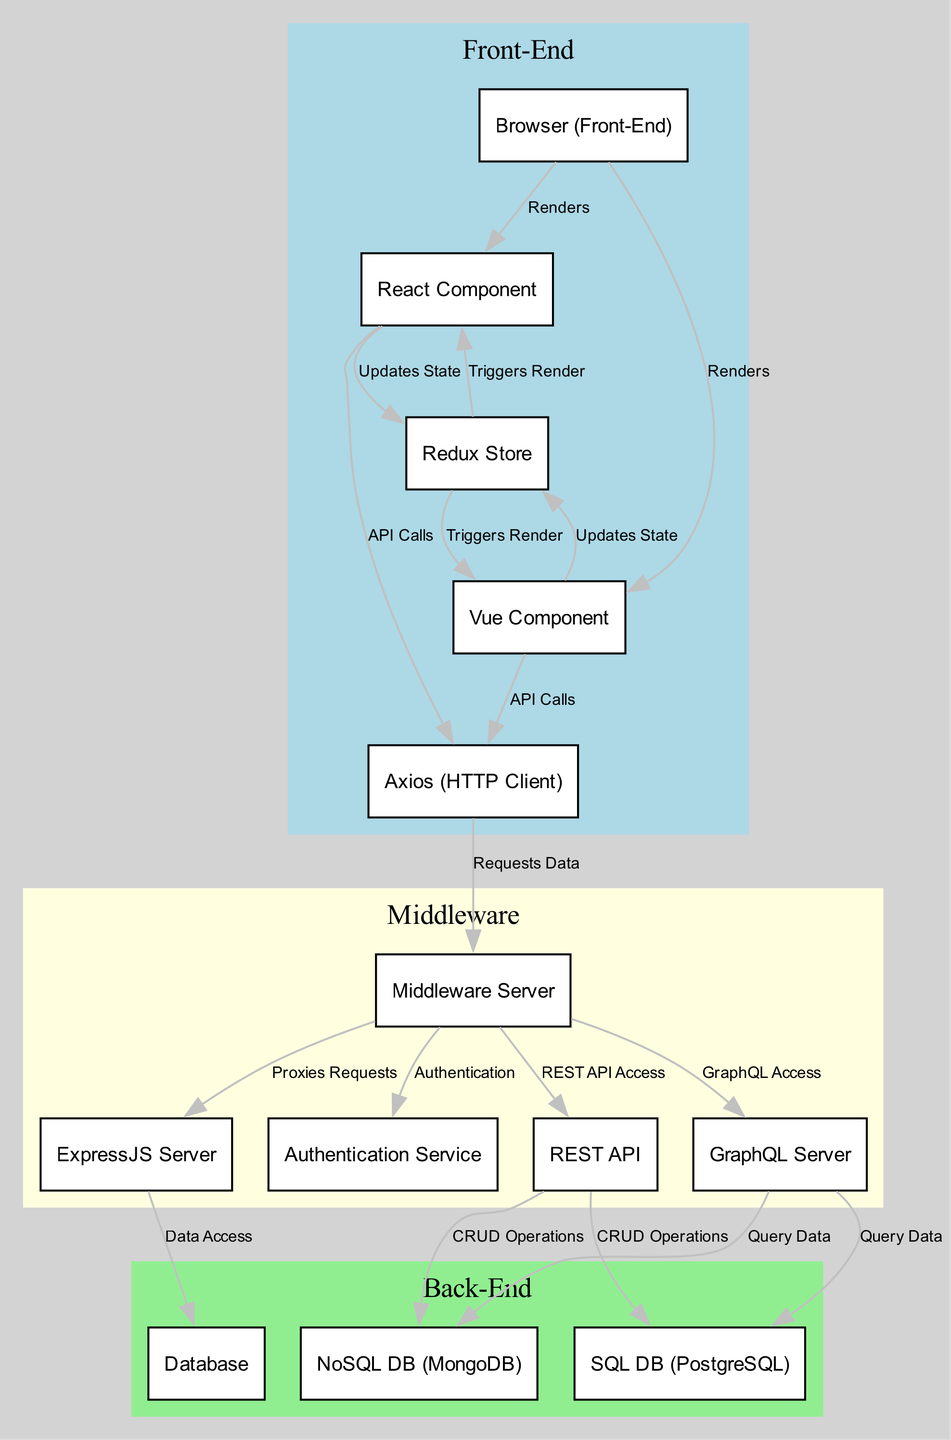What is the total number of nodes in the diagram? The diagram includes 13 nodes defined in the 'nodes' array, each representing a key component of the modern SPA architecture.
Answer: 13 Which component renders the Vue Component? The edge from node '1' (Browser) to node '3' (Vue Component) indicates that the Browser renders the Vue Component as a part of the front-end.
Answer: Browser How many CRUD operations are associated with the REST API? There are two connections from the REST API (node '9'), both connecting to NoSQL DB (node '12') and SQL DB (node '13'), indicating that CRUD operations can be performed on both databases.
Answer: 2 What triggers a render in the React Component? The edge from the Redux Store (node '4') to the React Component (node '2') shows that the Redux Store triggers a render when it updates the state, indicating a direct relationship.
Answer: Redux Store Which node handles authentication? The connection from Middleware Server (node '6') to Authentication Service (node '8') indicates that the Middleware Server handles the authentication process in the application.
Answer: Middleware Server If Axios requests data, which node does it communicate with? The edge from Axios (node '5') to Middleware Server (node '6') shows that when Axios makes a request, it communicates directly with the Middleware Server.
Answer: Middleware Server How many types of databases are referenced in the diagram? The diagram mentions three types of databases: NoSQL DB (MongoDB), SQL DB (PostgreSQL), and an abstract Database node, totaling three distinct types.
Answer: 3 Which two components are connected by the label "Proxies Requests"? The edge from Middleware Server (node '6') to ExpressJS Server (node '7') is labeled as "Proxies Requests," indicating that Middleware Server communicates with ExpressJS Server in this manner.
Answer: ExpressJS Server What is the relationship between the Redux Store and the components? The edges from nodes '2' and '3' (React and Vue Components) to node '4' (Redux Store) are labeled "Updates State," showing that both components update the state in the Redux Store.
Answer: Updates State 